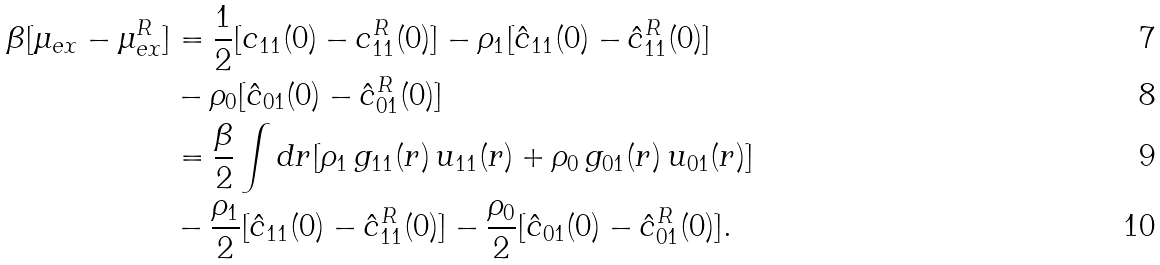<formula> <loc_0><loc_0><loc_500><loc_500>\beta [ \mu _ { e x } - \mu _ { e x } ^ { R } ] & = \frac { 1 } { 2 } [ c _ { 1 1 } ( 0 ) - c _ { 1 1 } ^ { R } ( 0 ) ] - \rho _ { 1 } [ \hat { c } _ { 1 1 } ( 0 ) - \hat { c } _ { 1 1 } ^ { R } ( 0 ) ] \\ & - \rho _ { 0 } [ \hat { c } _ { 0 1 } ( 0 ) - \hat { c } _ { 0 1 } ^ { R } ( 0 ) ] \\ & = \frac { \beta } { 2 } \int d { r } [ \rho _ { 1 } \, g _ { 1 1 } ( r ) \, u _ { 1 1 } ( r ) + \rho _ { 0 } \, g _ { 0 1 } ( r ) \, u _ { 0 1 } ( r ) ] \\ & - \frac { \rho _ { 1 } } { 2 } [ \hat { c } _ { 1 1 } ( 0 ) - \hat { c } _ { 1 1 } ^ { R } ( 0 ) ] - \frac { \rho _ { 0 } } { 2 } [ \hat { c } _ { 0 1 } ( 0 ) - \hat { c } _ { 0 1 } ^ { R } ( 0 ) ] .</formula> 